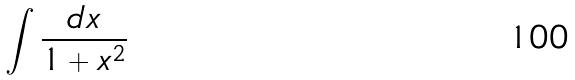<formula> <loc_0><loc_0><loc_500><loc_500>\int \frac { d x } { 1 + x ^ { 2 } }</formula> 